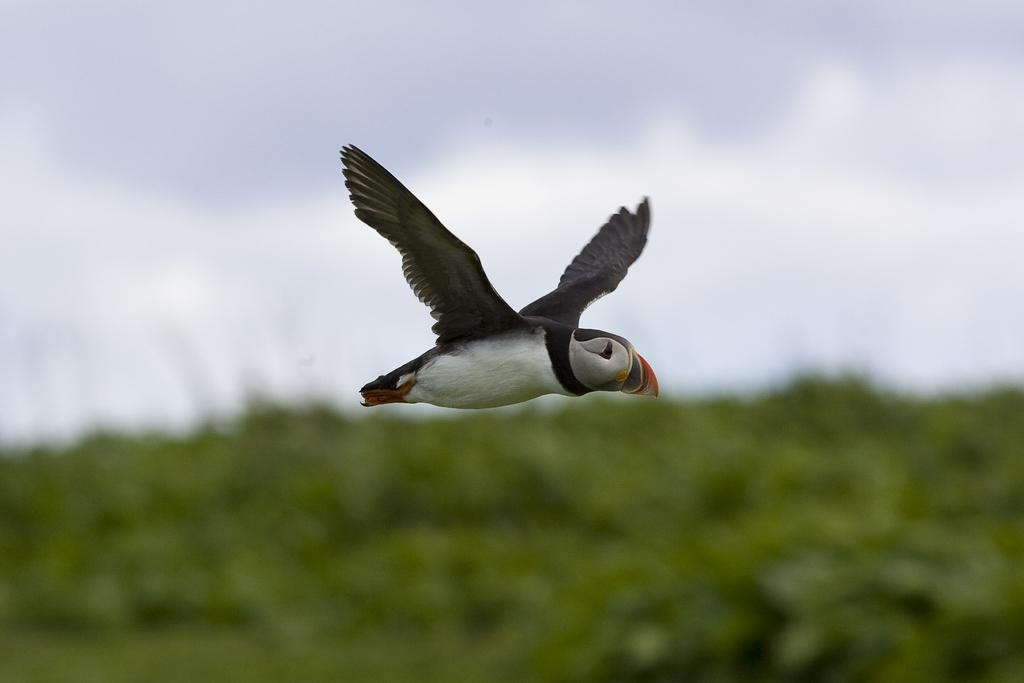What is happening in the foreground of the image? There is a bird flying in the air in the foreground of the image. What can be seen at the bottom part of the image? There is greenery in the bottom part of the image. What is visible in the top part of the image? The sky is visible in the top part of the image. Can you describe the sky in the image? There is at least one cloud in the sky. How many friends are visible in the image? There are no friends visible in the image; it features a bird flying in the air and greenery at the bottom. What holiday is being celebrated in the image? There is no indication of a holiday being celebrated in the image. 